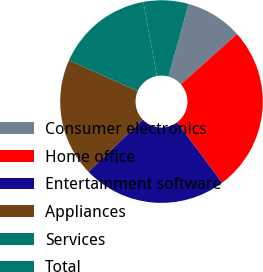Convert chart. <chart><loc_0><loc_0><loc_500><loc_500><pie_chart><fcel>Consumer electronics<fcel>Home office<fcel>Entertainment software<fcel>Appliances<fcel>Services<fcel>Total<nl><fcel>9.09%<fcel>26.41%<fcel>23.01%<fcel>18.86%<fcel>15.47%<fcel>7.17%<nl></chart> 